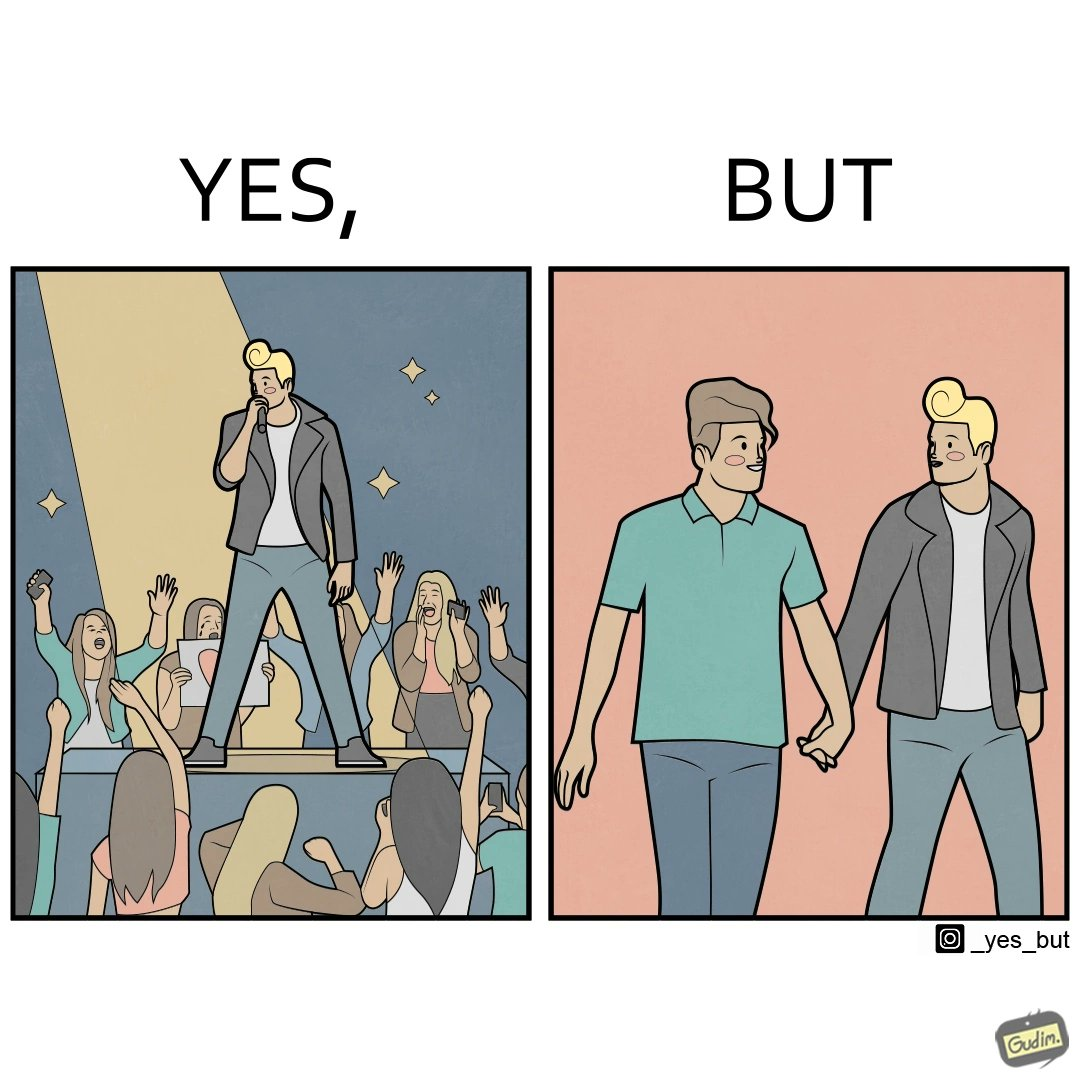Does this image contain satire or humor? Yes, this image is satirical. 